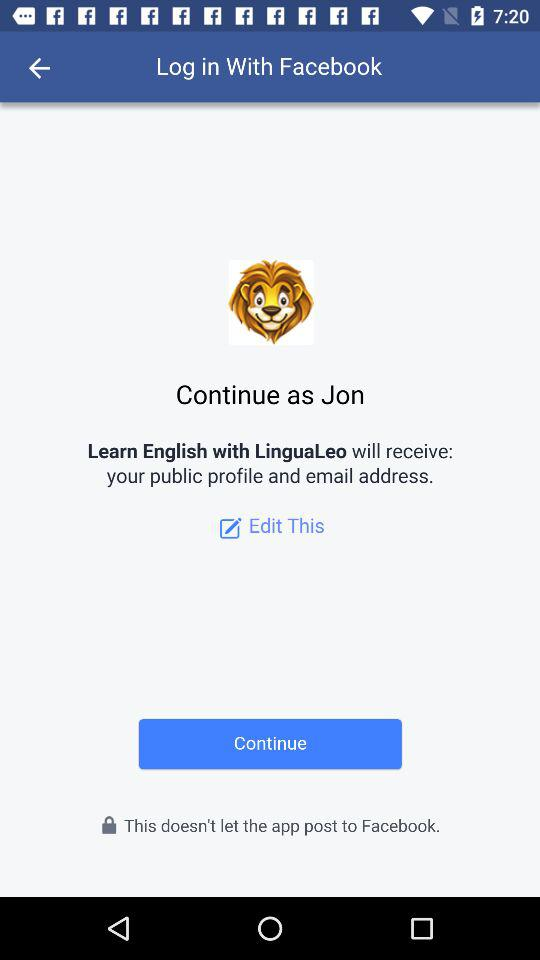What is the name of the user? The name of the user is "Jon". 